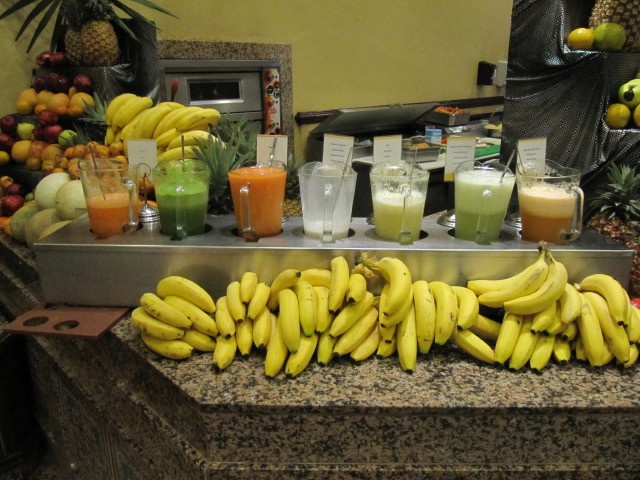Describe the objects in this image and their specific colors. I can see banana in darkgreen, olive, khaki, and black tones, banana in darkgreen, olive, and gold tones, banana in darkgreen, olive, and gold tones, banana in darkgreen, olive, khaki, and black tones, and banana in darkgreen, olive, khaki, and gold tones in this image. 